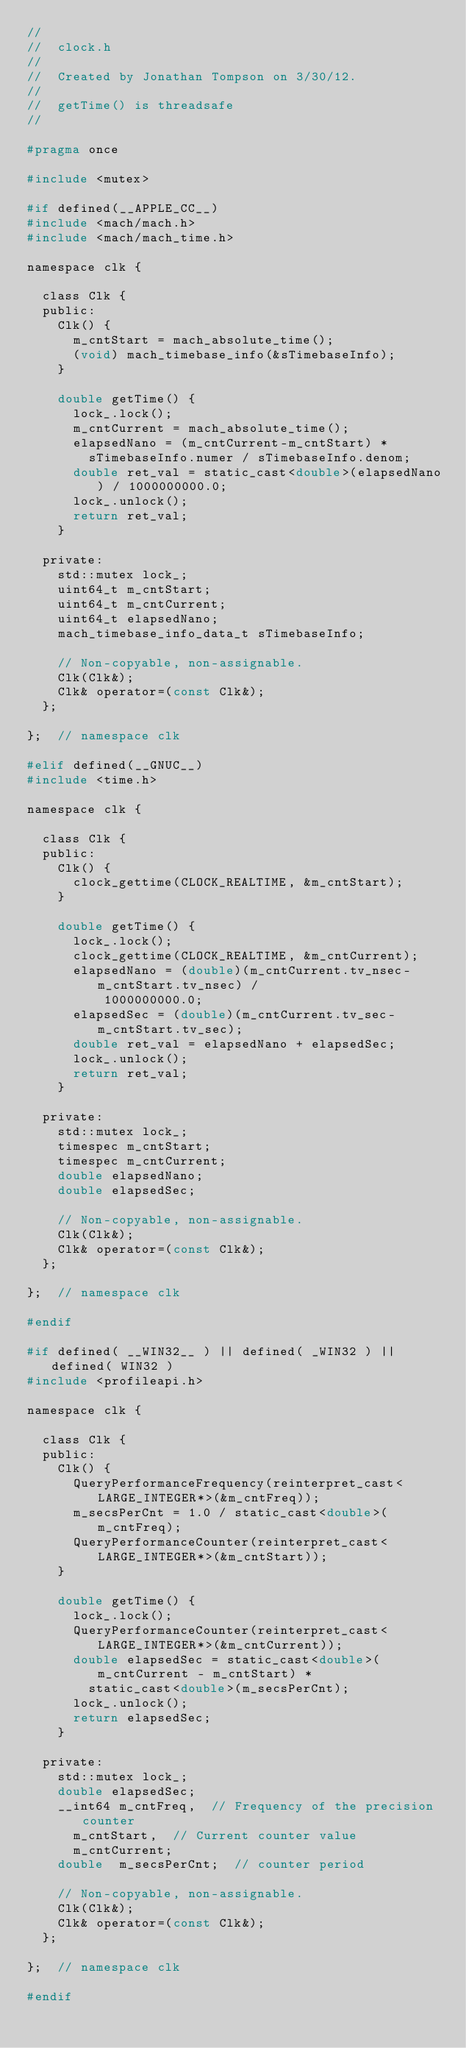Convert code to text. <code><loc_0><loc_0><loc_500><loc_500><_C_>//
//  clock.h
//
//  Created by Jonathan Tompson on 3/30/12.
//
//  getTime() is threadsafe
//

#pragma once

#include <mutex>

#if defined(__APPLE_CC__)
#include <mach/mach.h>
#include <mach/mach_time.h>

namespace clk {

  class Clk {
  public:
    Clk() {
      m_cntStart = mach_absolute_time();
      (void) mach_timebase_info(&sTimebaseInfo);
    }

    double getTime() {
      lock_.lock();
      m_cntCurrent = mach_absolute_time();
      elapsedNano = (m_cntCurrent-m_cntStart) * 
        sTimebaseInfo.numer / sTimebaseInfo.denom;
      double ret_val = static_cast<double>(elapsedNano) / 1000000000.0;
      lock_.unlock();
      return ret_val;
    }

  private:
    std::mutex lock_;
    uint64_t m_cntStart;
    uint64_t m_cntCurrent;
    uint64_t elapsedNano;
    mach_timebase_info_data_t sTimebaseInfo;

    // Non-copyable, non-assignable.
    Clk(Clk&);
    Clk& operator=(const Clk&);
  };

};  // namespace clk 

#elif defined(__GNUC__)
#include <time.h>

namespace clk {

  class Clk {
  public:
    Clk() {
      clock_gettime(CLOCK_REALTIME, &m_cntStart);
    }

    double getTime() {
      lock_.lock();
      clock_gettime(CLOCK_REALTIME, &m_cntCurrent);
      elapsedNano = (double)(m_cntCurrent.tv_nsec-m_cntStart.tv_nsec) /
          1000000000.0;
      elapsedSec = (double)(m_cntCurrent.tv_sec-m_cntStart.tv_sec);
      double ret_val = elapsedNano + elapsedSec;
      lock_.unlock();
      return ret_val;
    }

  private:
    std::mutex lock_;
    timespec m_cntStart;
    timespec m_cntCurrent;
    double elapsedNano;
    double elapsedSec;

    // Non-copyable, non-assignable.
    Clk(Clk&);
    Clk& operator=(const Clk&);
  };

};  // namespace clk

#endif

#if defined( __WIN32__ ) || defined( _WIN32 ) || defined( WIN32 )
#include <profileapi.h>

namespace clk {

  class Clk {
  public:
    Clk() {
      QueryPerformanceFrequency(reinterpret_cast<LARGE_INTEGER*>(&m_cntFreq));
      m_secsPerCnt = 1.0 / static_cast<double>(m_cntFreq);
      QueryPerformanceCounter(reinterpret_cast<LARGE_INTEGER*>(&m_cntStart));
    }

    double getTime() {
      lock_.lock();
      QueryPerformanceCounter(reinterpret_cast<LARGE_INTEGER*>(&m_cntCurrent));
      double elapsedSec = static_cast<double>(m_cntCurrent - m_cntStart) * 
        static_cast<double>(m_secsPerCnt);
      lock_.unlock();
      return elapsedSec;
    }

  private:
    std::mutex lock_;
    double elapsedSec;
    __int64 m_cntFreq,  // Frequency of the precision counter
      m_cntStart,  // Current counter value
      m_cntCurrent;
    double  m_secsPerCnt;  // counter period

    // Non-copyable, non-assignable.
    Clk(Clk&);
    Clk& operator=(const Clk&);
  };

};  // namespace clk

#endif
</code> 